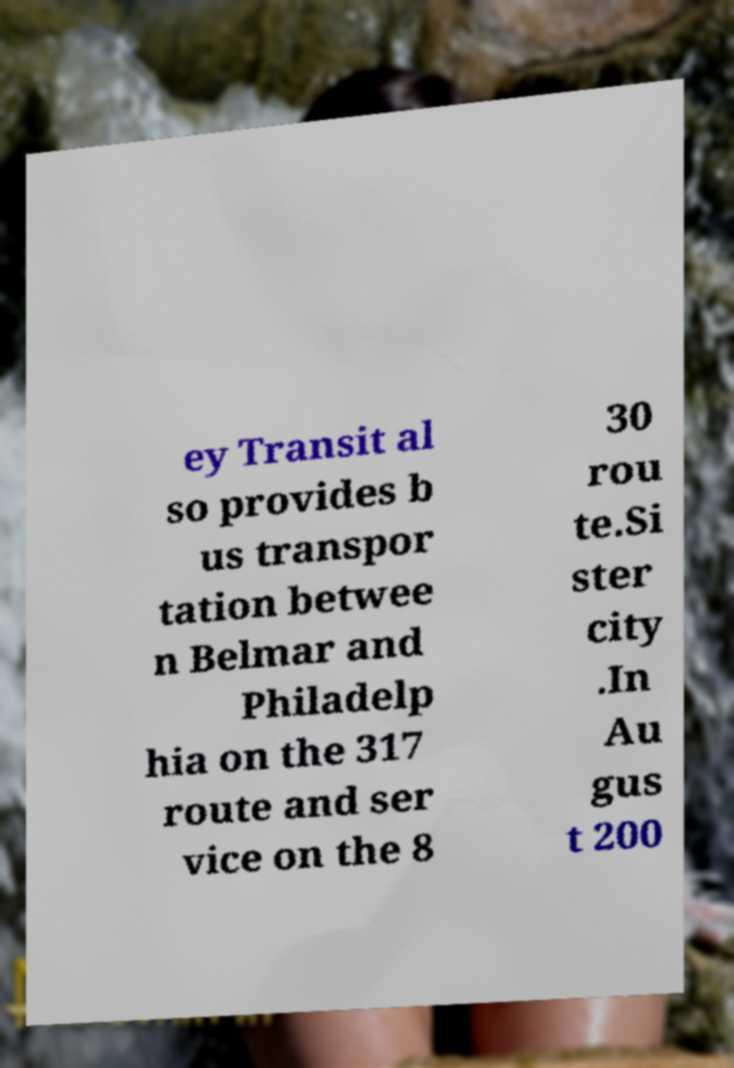Please read and relay the text visible in this image. What does it say? ey Transit al so provides b us transpor tation betwee n Belmar and Philadelp hia on the 317 route and ser vice on the 8 30 rou te.Si ster city .In Au gus t 200 